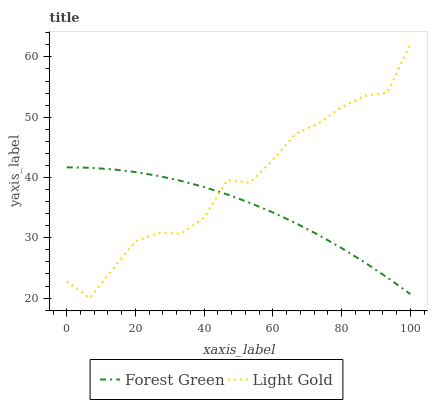Does Forest Green have the minimum area under the curve?
Answer yes or no. Yes. Does Light Gold have the maximum area under the curve?
Answer yes or no. Yes. Does Light Gold have the minimum area under the curve?
Answer yes or no. No. Is Forest Green the smoothest?
Answer yes or no. Yes. Is Light Gold the roughest?
Answer yes or no. Yes. Is Light Gold the smoothest?
Answer yes or no. No. Does Light Gold have the lowest value?
Answer yes or no. Yes. Does Light Gold have the highest value?
Answer yes or no. Yes. Does Forest Green intersect Light Gold?
Answer yes or no. Yes. Is Forest Green less than Light Gold?
Answer yes or no. No. Is Forest Green greater than Light Gold?
Answer yes or no. No. 